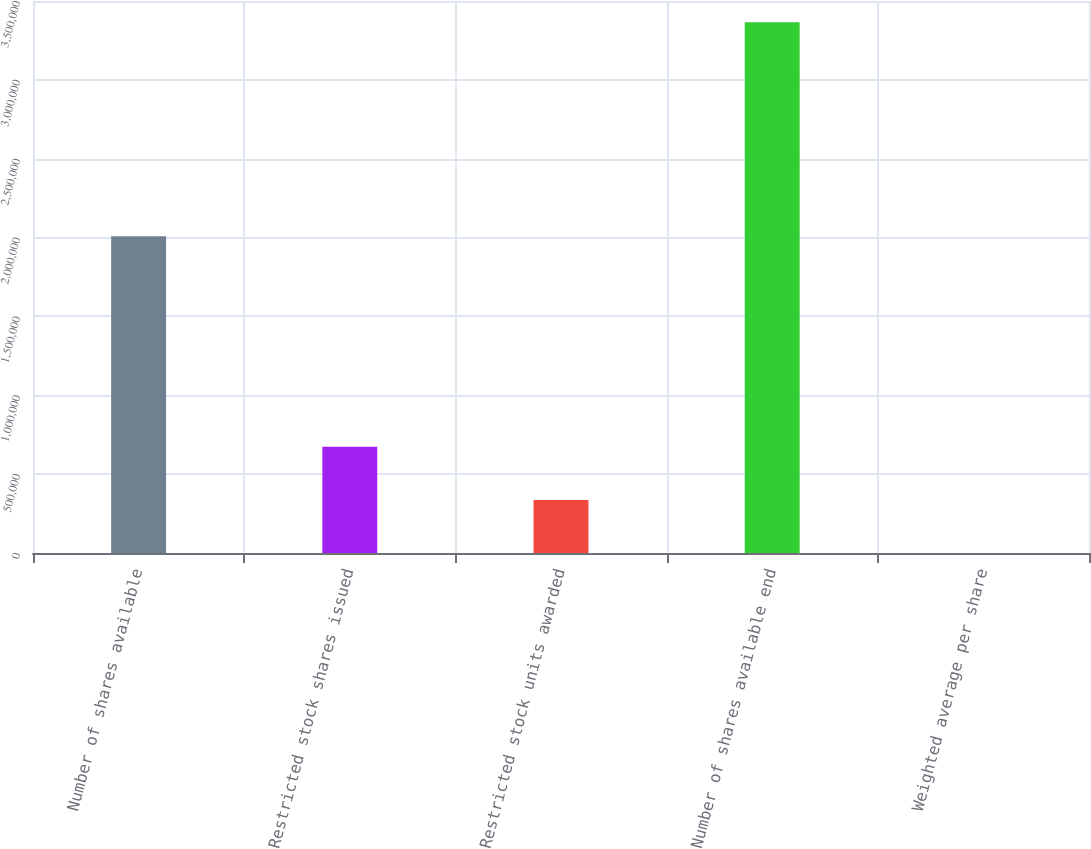<chart> <loc_0><loc_0><loc_500><loc_500><bar_chart><fcel>Number of shares available<fcel>Restricted stock shares issued<fcel>Restricted stock units awarded<fcel>Number of shares available end<fcel>Weighted average per share<nl><fcel>2.00915e+06<fcel>673024<fcel>336527<fcel>3.365e+06<fcel>30.54<nl></chart> 